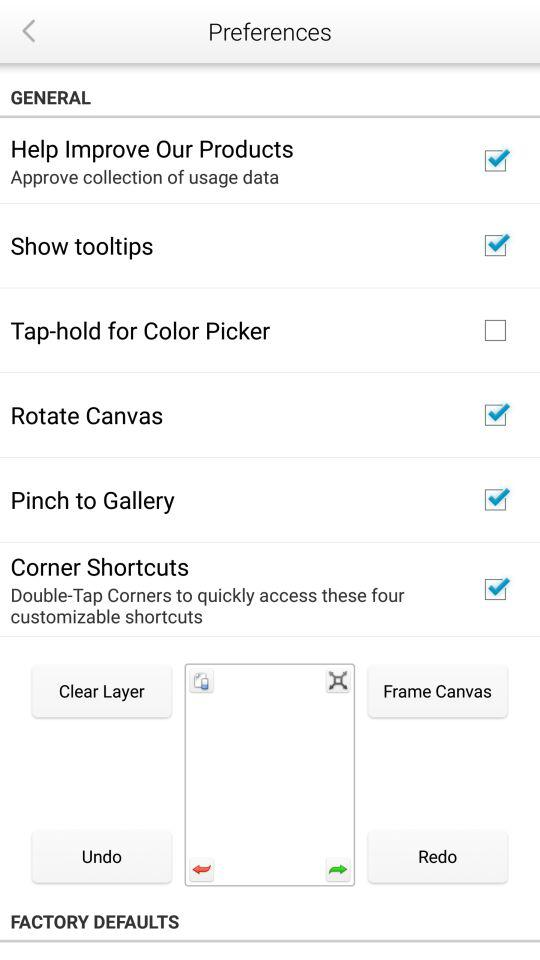What is the name of the application?
When the provided information is insufficient, respond with <no answer>. <no answer> 